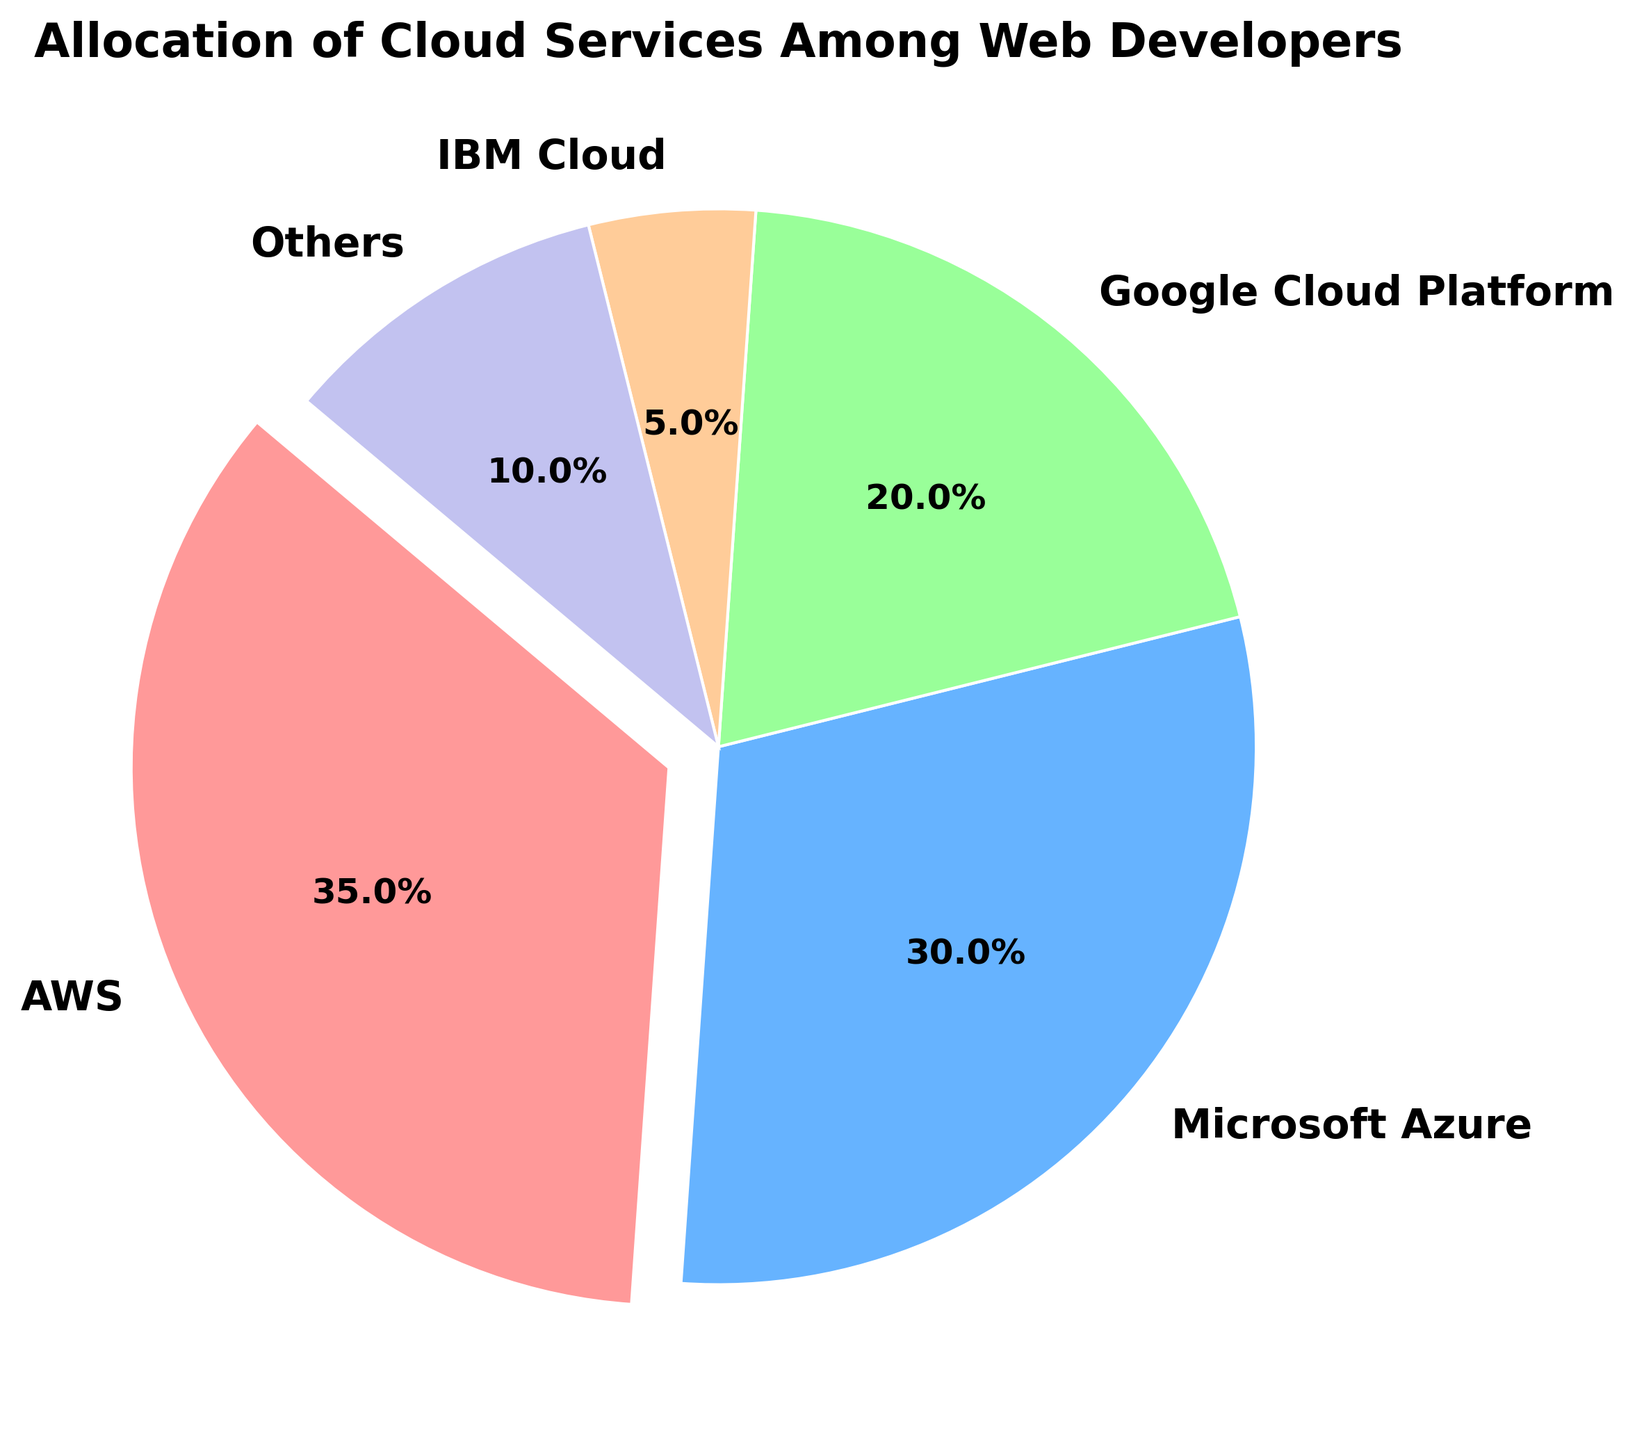Which cloud service has the highest allocation among web developers? According to the pie chart, AWS has the highest allocation percentage compared to the other services.
Answer: AWS Which cloud service has the least allocation among web developers? Based on the pie chart, IBM Cloud has the smallest slice, indicating it has the least allocation percentage.
Answer: IBM Cloud What is the combined allocation percentage for Google Cloud Platform and others? From the pie chart percentages, Google Cloud Platform is 20% and others is 10%. Summing these: 20% + 10% = 30%.
Answer: 30% How much percent more is the allocation of Microsoft Azure compared to IBM Cloud? Microsoft Azure has 30% while IBM Cloud has 5%. Subtracting these: 30% - 5% = 25%.
Answer: 25% Which two cloud services together make up exactly half of the allocation? Google Cloud Platform is 20% and others is 10%. Adding these percentage slices yields 20% + 10% = 30%. Neither pair sums up to exactly 50%. AWS (35%) + IBM Cloud (5%) = 40%, Microsoft Azure (30%) + Google Cloud Platform (20%) = 50%.
Answer: Microsoft Azure, Google Cloud Platform Which services have an allocation percentage that is less than 25% each? From the pie chart, Google Cloud Platform has 20%, IBM Cloud has 5%, and others have 10%. All are less than 25%.
Answer: Google Cloud Platform, IBM Cloud, Others What is the total allocation for Azure and services allocated under 'Others'? Microsoft Azure is 30% and others is 10%. Summing these: 30% + 10% = 40%.
Answer: 40% By how much does AWS's allocation exceed Google's allocation? AWS has an allocation of 35% and Google Cloud Platform has 20%. Subtracting these: 35% - 20% = 15%.
Answer: 15% If you combine all the percentages for AWS, Microsoft Azure, and Google Cloud Platform, what is their total allocation? AWS is 35%, Microsoft Azure is 30%, and Google Cloud Platform is 20%. Adding these: 35% + 30% + 20% = 85%.
Answer: 85% Which slice of the pie chart is exploded or separated out? The description indicates that AWS's slice is exploded or separated out.
Answer: AWS 